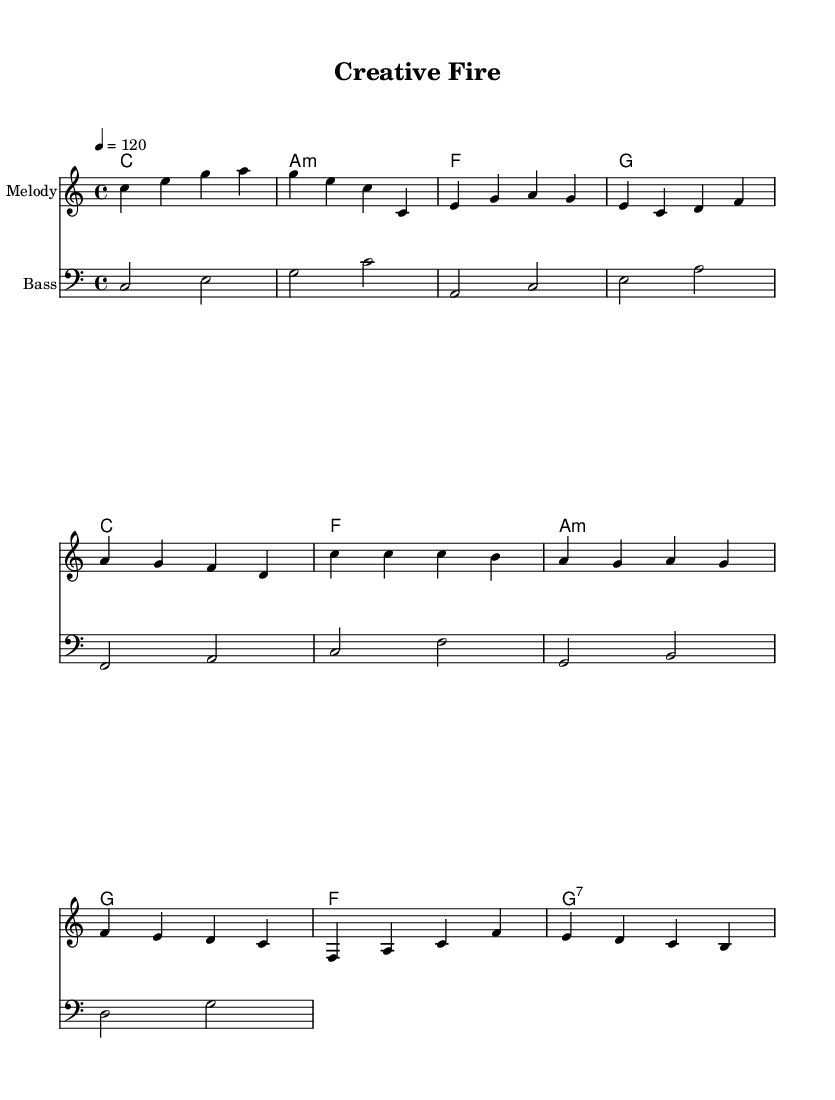What is the key signature of this music? The key signature shows no sharps or flats listed, which indicates that the piece is in C major.
Answer: C major What is the time signature of this piece? The time signature, noted at the beginning, is 4/4, meaning there are four beats in a measure.
Answer: 4/4 What is the tempo marking for this music? The tempo is indicated as "4 = 120," which means the quarter note gets a beat of 120 beats per minute.
Answer: 120 How many measures are there in the melody section? By analyzing the melody, there are a total of 8 measures present in the melody line.
Answer: 8 What chords are used in the chorus? Looking at the harmonies, the chords listed in the chorus are C, F, A minor, and G.
Answer: C, F, A minor, G What is the emotional theme of the lyrics? The lyrics focus on expressing one's creative passion and ambition, emphasizing exploration and personal expression.
Answer: Creative passion What is the structure type of this musical piece? The piece follows a common song structure, which includes an intro, verse, chorus, and bridge.
Answer: Intro, verse, chorus, bridge 